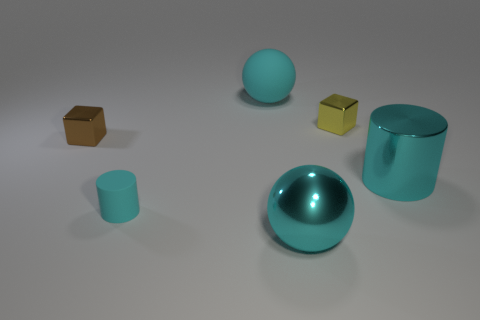Is there a large object?
Provide a short and direct response. Yes. What number of tiny brown metallic blocks are in front of the tiny block on the left side of the metallic ball?
Give a very brief answer. 0. The big thing that is behind the tiny brown thing has what shape?
Offer a terse response. Sphere. What is the material of the ball that is on the right side of the cyan sphere that is behind the large ball that is in front of the big cyan shiny cylinder?
Provide a short and direct response. Metal. What number of other things are the same size as the yellow shiny cube?
Ensure brevity in your answer.  2. There is a tiny brown thing that is the same shape as the small yellow object; what is it made of?
Keep it short and to the point. Metal. The big rubber thing is what color?
Offer a very short reply. Cyan. The tiny block that is on the right side of the object that is in front of the matte cylinder is what color?
Your response must be concise. Yellow. Do the tiny cylinder and the tiny metal thing that is right of the small cylinder have the same color?
Give a very brief answer. No. There is a cylinder on the left side of the big cyan ball that is behind the tiny brown object; how many tiny shiny blocks are behind it?
Provide a succinct answer. 2. 